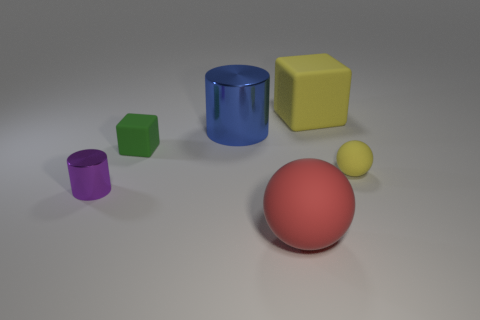How many objects are things that are to the left of the blue metal cylinder or tiny objects right of the blue metal object?
Provide a short and direct response. 3. What number of other objects are there of the same size as the red matte thing?
Provide a short and direct response. 2. There is a rubber object on the left side of the big blue cylinder; does it have the same color as the big matte ball?
Keep it short and to the point. No. What size is the thing that is both behind the small green block and in front of the large yellow block?
Provide a short and direct response. Large. How many tiny objects are yellow matte balls or cyan blocks?
Make the answer very short. 1. There is a small matte object that is to the left of the yellow matte block; what shape is it?
Make the answer very short. Cube. What number of large gray metallic balls are there?
Offer a very short reply. 0. Is the big cube made of the same material as the small cube?
Make the answer very short. Yes. Are there more big spheres to the right of the purple cylinder than big red shiny cylinders?
Ensure brevity in your answer.  Yes. What number of objects are big brown metal cylinders or big matte objects behind the green matte thing?
Offer a very short reply. 1. 